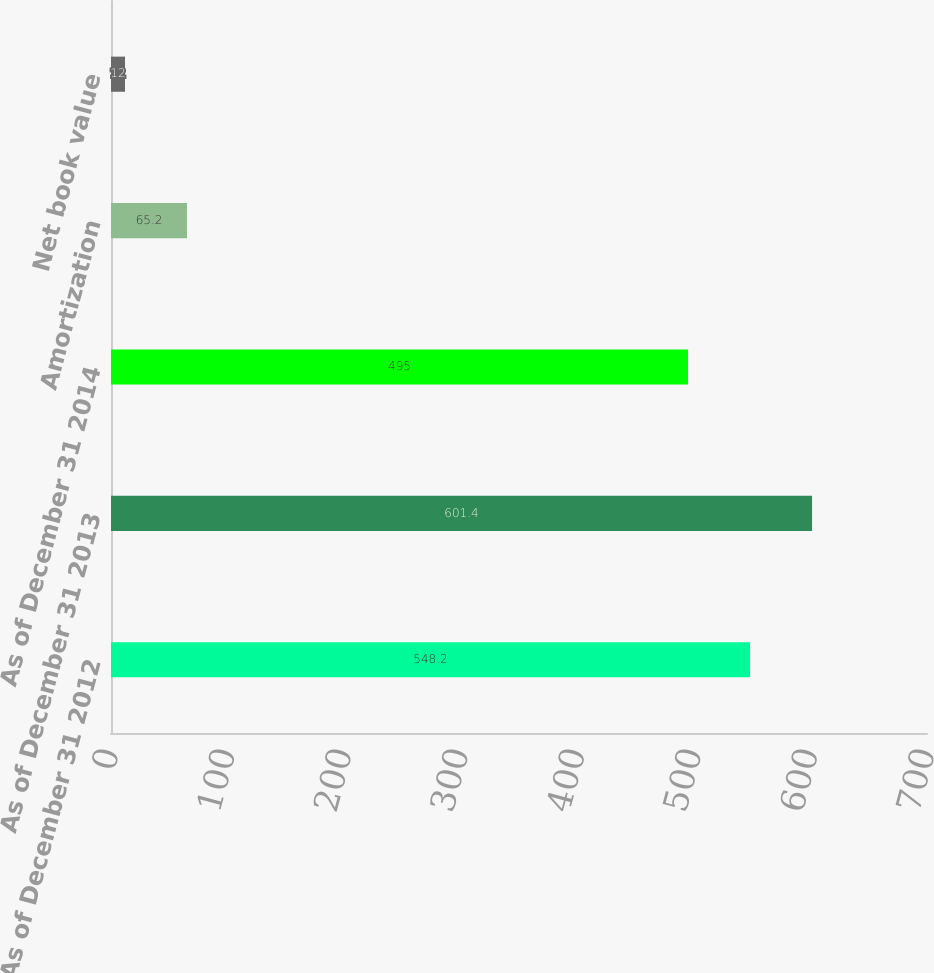Convert chart to OTSL. <chart><loc_0><loc_0><loc_500><loc_500><bar_chart><fcel>As of December 31 2012<fcel>As of December 31 2013<fcel>As of December 31 2014<fcel>Amortization<fcel>Net book value<nl><fcel>548.2<fcel>601.4<fcel>495<fcel>65.2<fcel>12<nl></chart> 